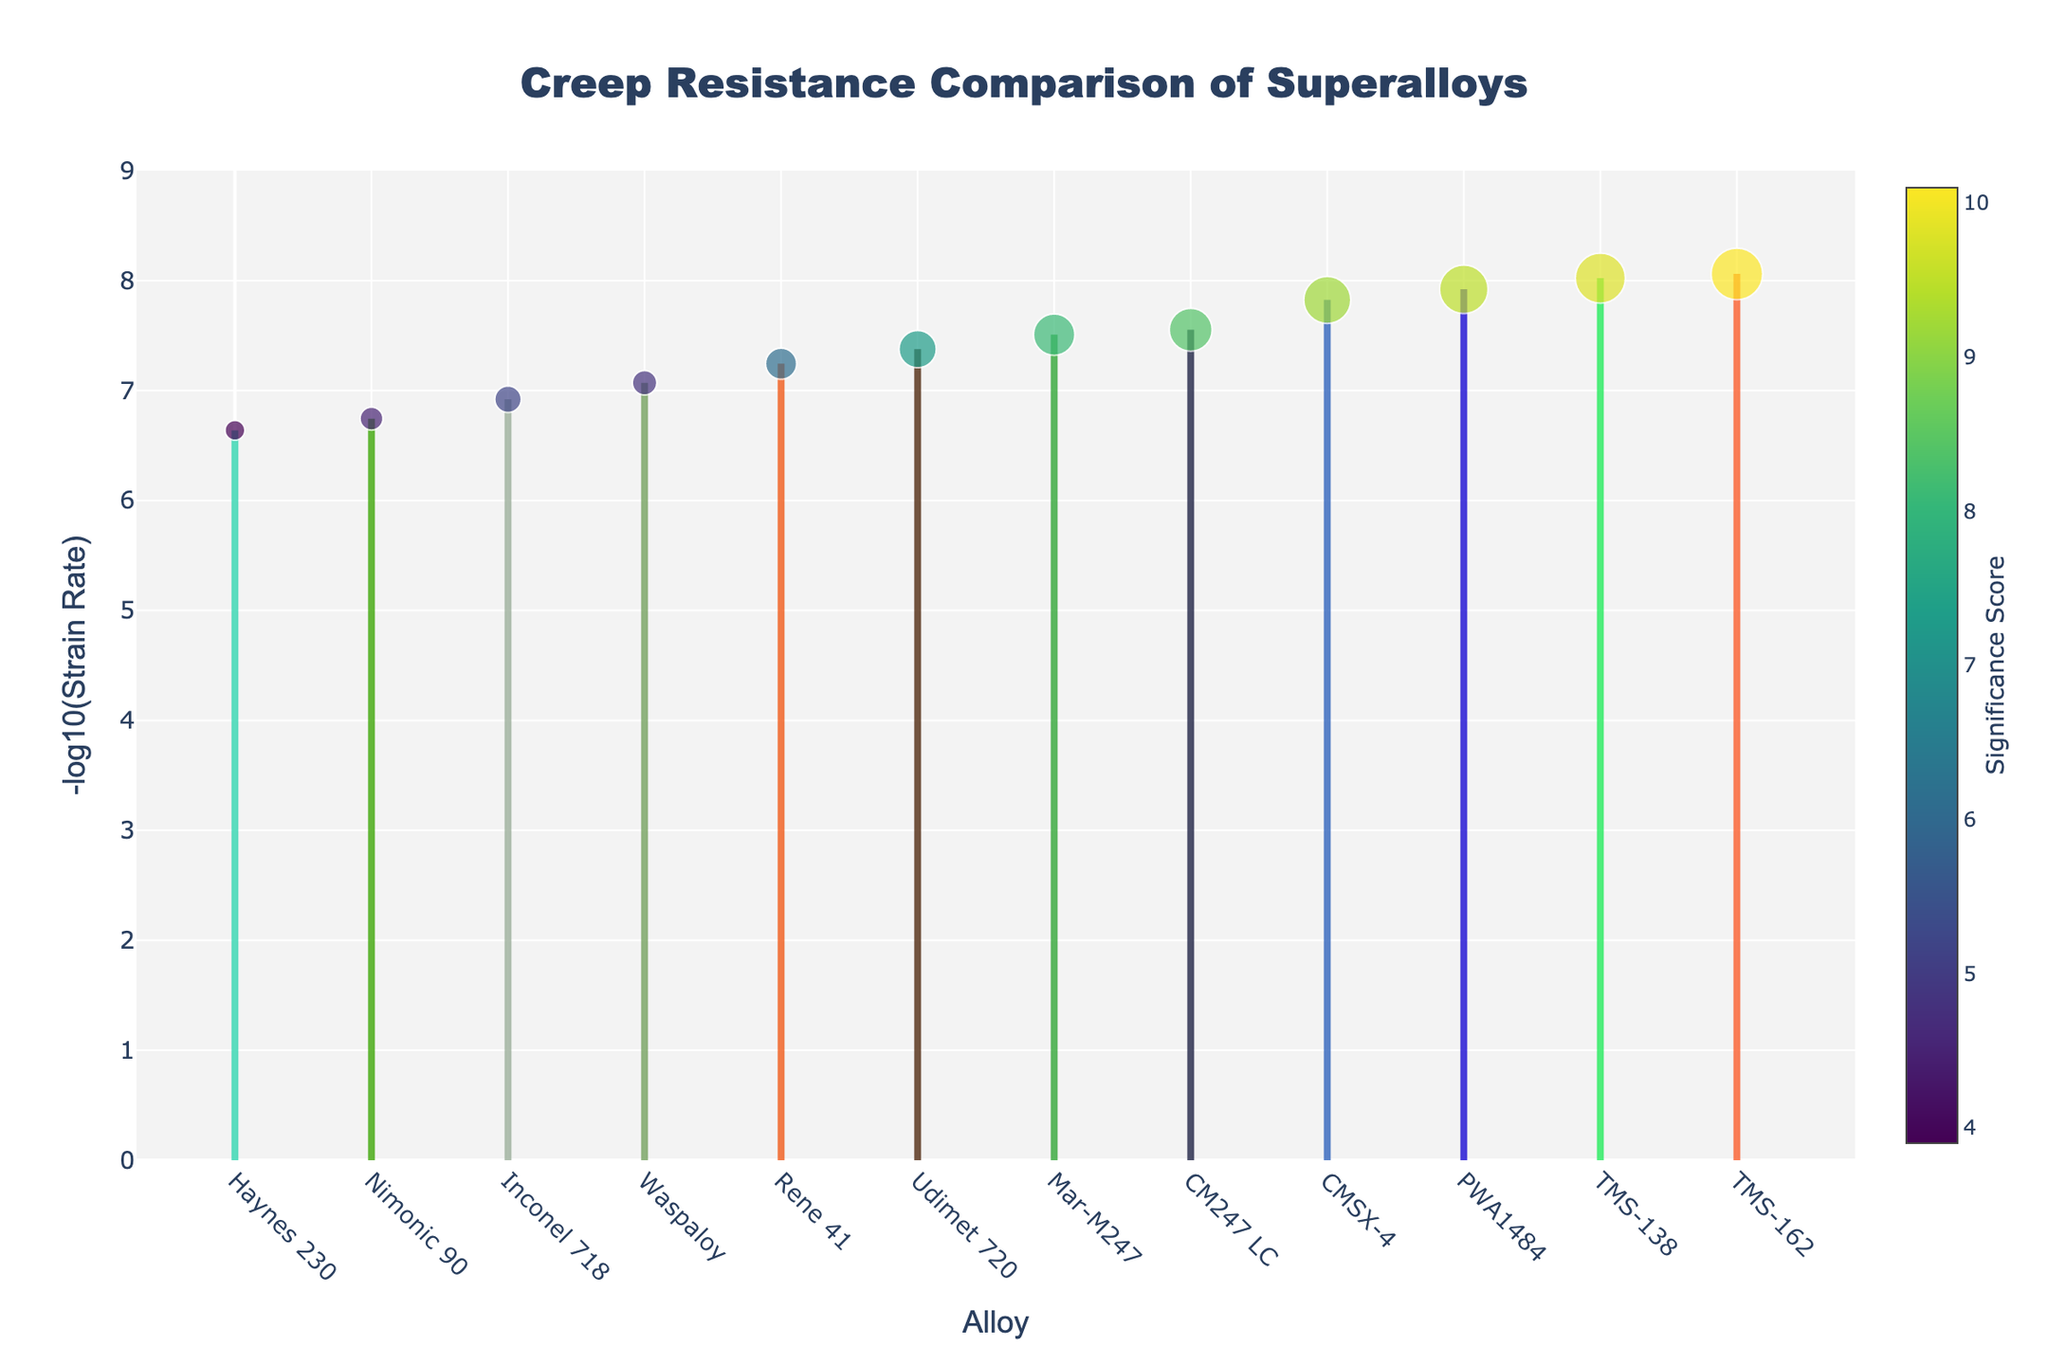what is the title of the plot? The title of the plot is displayed at the top center, in a large, bold font.
Answer: Creep Resistance Comparison of Superalloys Which alloy shows the highest significance score? The highest significance score corresponds to the largest marker in a bright color.
Answer: TMS-162 How many data points are shown in the figure? Count the number of markers (one per alloy).
Answer: 12 Which alloy has the second smallest strain rate? The second smallest strain rate corresponds to the second largest y-value (-log10(Strain Rate)).
Answer: TMS-138 What is the range of the y-axis? The y-axis range is shown on the left, with labels for the minimum and maximum values.
Answer: 0 to 9 Which two alloys have the closest significance scores? Look for markers that are similarly sized in the plot.
Answer: CM247 LC and Mar-M247 What is the strain rate of CMSX-4 in scientific notation? Hover over the marker for CMSX-4 to see the detailed information including the strain rate.
Answer: 1.5e-8 How does the strain rate of TMS-162 compare to that of Rene 41? Compare the y-values of TMS-162 and Rene 41, where a higher y-value means a smaller strain rate.
Answer: TMS-162 has a smaller strain rate Which alloy has the highest y-value and what does it indicate? The y-value is -log10(Strain Rate), so the highest value indicates the smallest strain rate.
Answer: TMS-162 What is the significance score of Mar-M247 and is it higher or lower compared to Udimet 720? Hover over the markers for both alloys to find their significance scores and compare.
Answer: Mar-M247: 8.1, Higher 